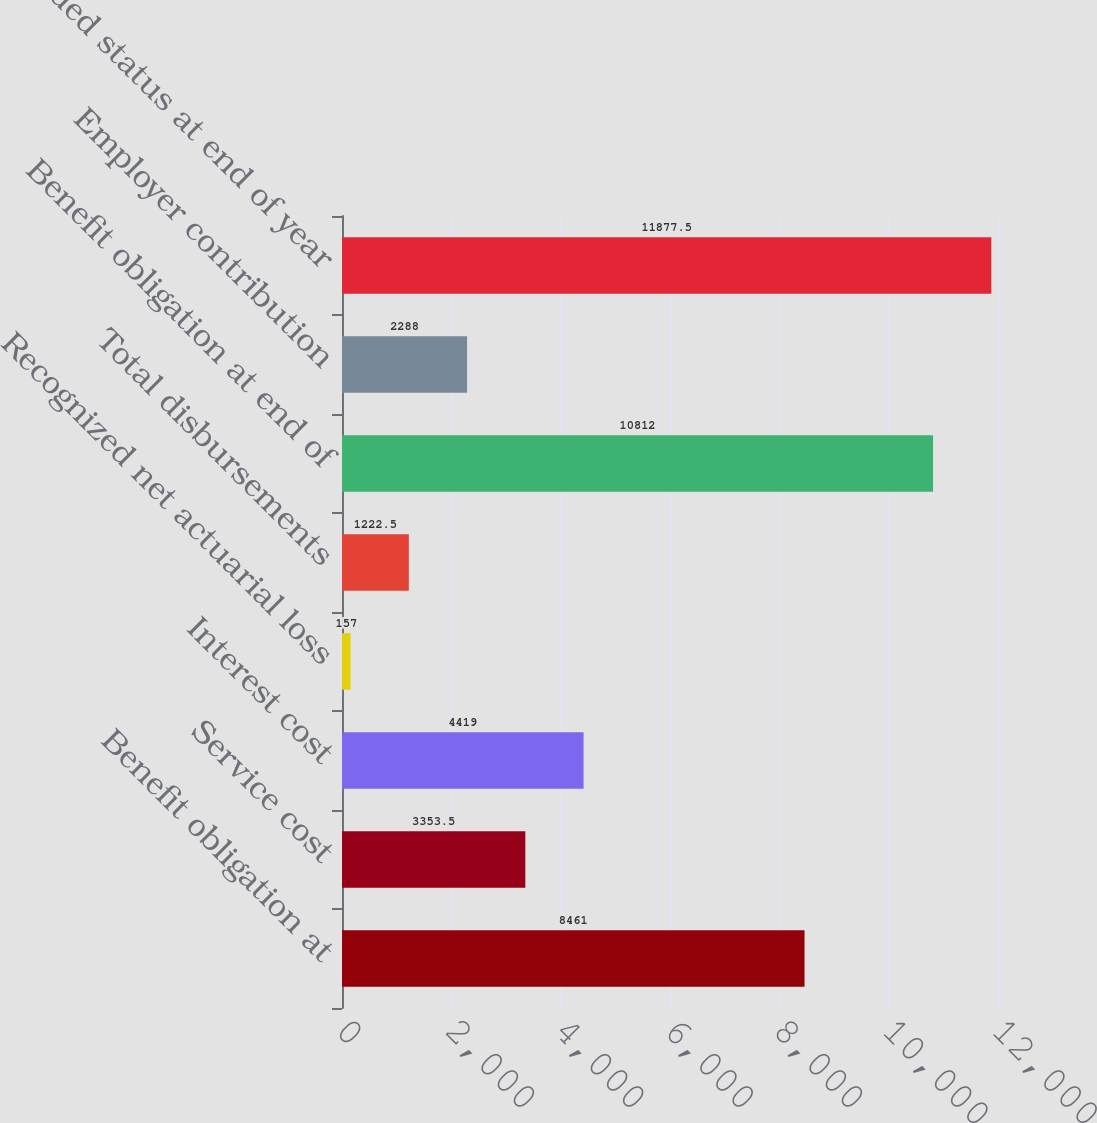Convert chart. <chart><loc_0><loc_0><loc_500><loc_500><bar_chart><fcel>Benefit obligation at<fcel>Service cost<fcel>Interest cost<fcel>Recognized net actuarial loss<fcel>Total disbursements<fcel>Benefit obligation at end of<fcel>Employer contribution<fcel>Funded status at end of year<nl><fcel>8461<fcel>3353.5<fcel>4419<fcel>157<fcel>1222.5<fcel>10812<fcel>2288<fcel>11877.5<nl></chart> 